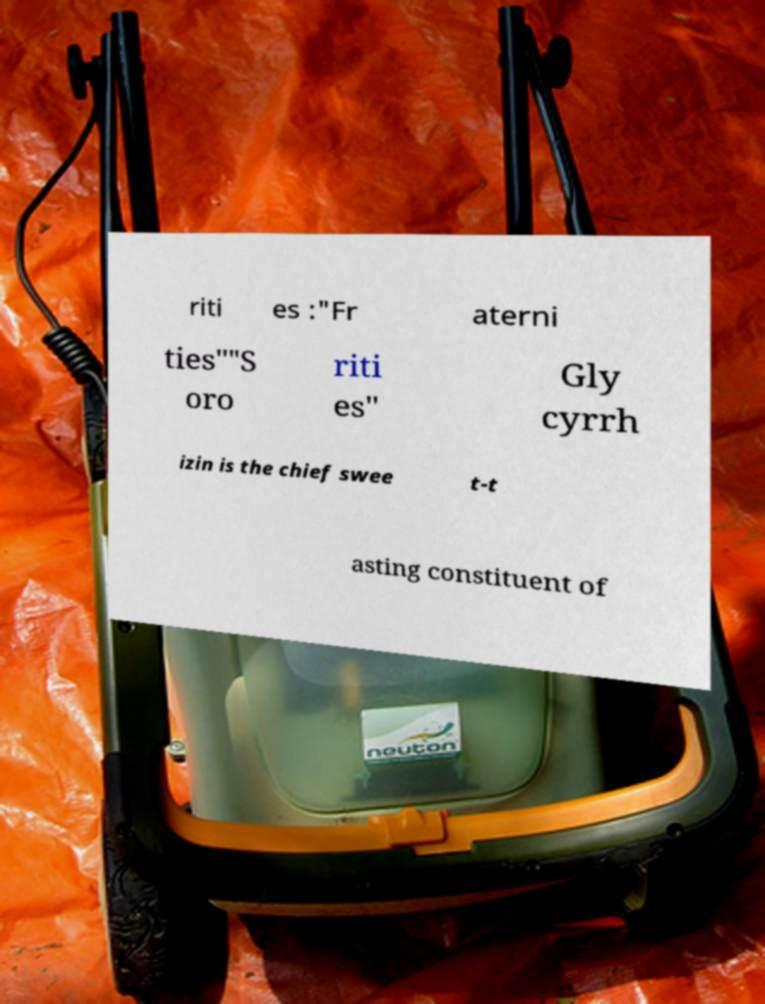Can you accurately transcribe the text from the provided image for me? riti es :"Fr aterni ties""S oro riti es" Gly cyrrh izin is the chief swee t-t asting constituent of 